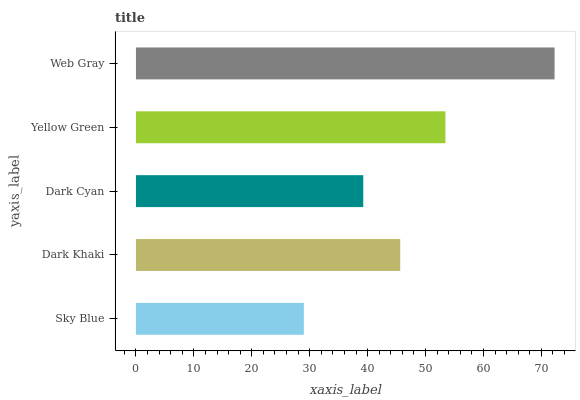Is Sky Blue the minimum?
Answer yes or no. Yes. Is Web Gray the maximum?
Answer yes or no. Yes. Is Dark Khaki the minimum?
Answer yes or no. No. Is Dark Khaki the maximum?
Answer yes or no. No. Is Dark Khaki greater than Sky Blue?
Answer yes or no. Yes. Is Sky Blue less than Dark Khaki?
Answer yes or no. Yes. Is Sky Blue greater than Dark Khaki?
Answer yes or no. No. Is Dark Khaki less than Sky Blue?
Answer yes or no. No. Is Dark Khaki the high median?
Answer yes or no. Yes. Is Dark Khaki the low median?
Answer yes or no. Yes. Is Web Gray the high median?
Answer yes or no. No. Is Web Gray the low median?
Answer yes or no. No. 